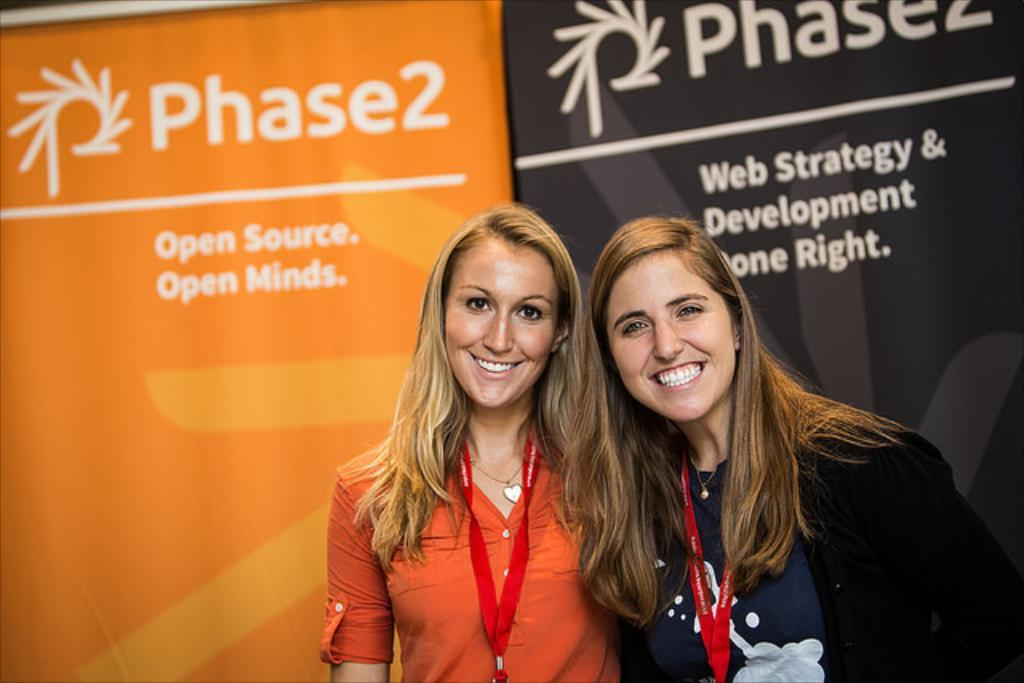How many people are in the image? There are two ladies in the image. What are the ladies wearing that can be seen in the image? The ladies are wearing ID tags. What position are the ladies in the image? The ladies are standing. What can be seen in the background of the image? There are two banners in the background of the image. What is written or depicted on the banners? There is text on the banners. What type of ship can be seen sailing in the background of the image? There is no ship present in the image; it features two ladies standing with banners in the background. Can you tell me how many drums are being played by the ladies in the image? There are no drums or any musical instruments visible in the image; the ladies are wearing ID tags and standing near banners. 